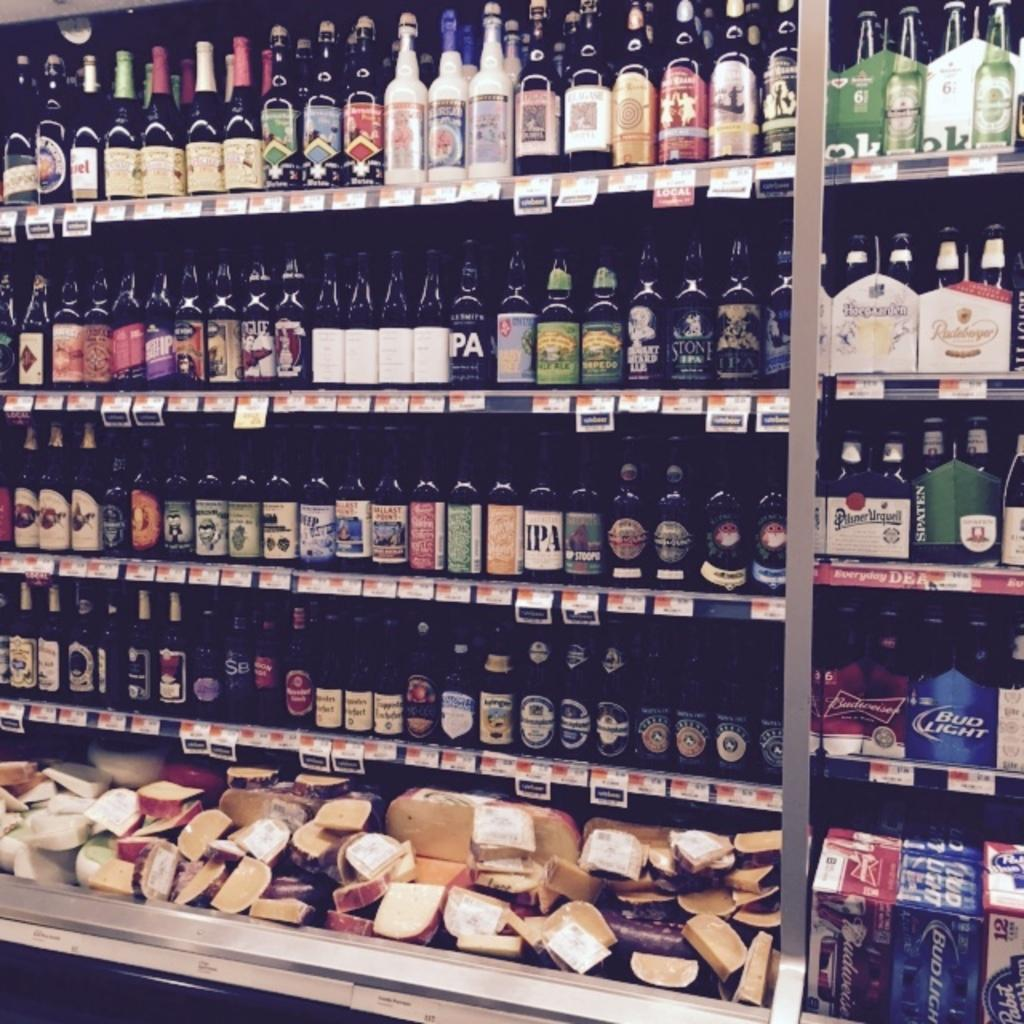<image>
Write a terse but informative summary of the picture. The extensive spirits and cheese selection includes Budweiser and Heineken. 